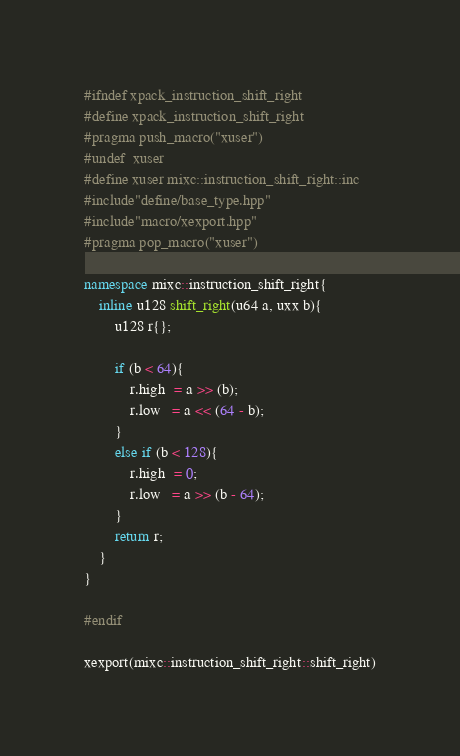Convert code to text. <code><loc_0><loc_0><loc_500><loc_500><_C++_>#ifndef xpack_instruction_shift_right
#define xpack_instruction_shift_right
#pragma push_macro("xuser")
#undef  xuser
#define xuser mixc::instruction_shift_right::inc
#include"define/base_type.hpp"
#include"macro/xexport.hpp"
#pragma pop_macro("xuser")

namespace mixc::instruction_shift_right{
    inline u128 shift_right(u64 a, uxx b){
        u128 r{};

        if (b < 64){
            r.high  = a >> (b);
            r.low   = a << (64 - b);
        }
        else if (b < 128){
            r.high  = 0;
            r.low   = a >> (b - 64);
        }
        return r;
    }
}

#endif

xexport(mixc::instruction_shift_right::shift_right)</code> 